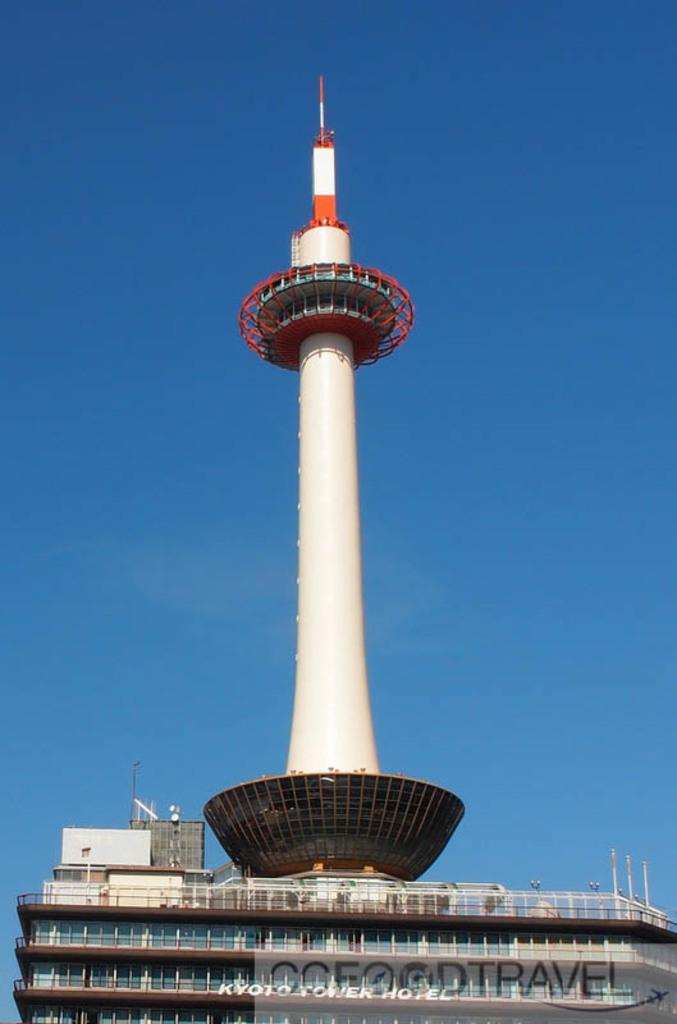What type of structure is located at the bottom of the image? There is a building at the bottom of the image. What can be seen in the center of the image? There is a tower in the center of the image. What is visible in the background of the image? The sky is visible in the background of the image. Where is the toothbrush located in the image? There is no toothbrush present in the image. What sound do the bells make in the image? There are no bells present in the image. 